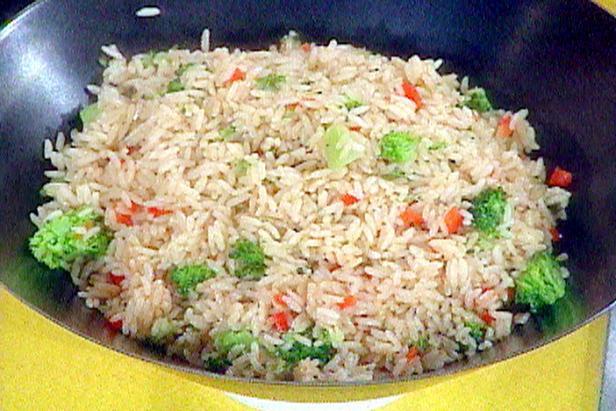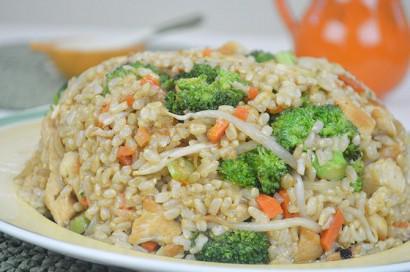The first image is the image on the left, the second image is the image on the right. For the images shown, is this caption "the rice on the left image is on a white plate" true? Answer yes or no. No. 